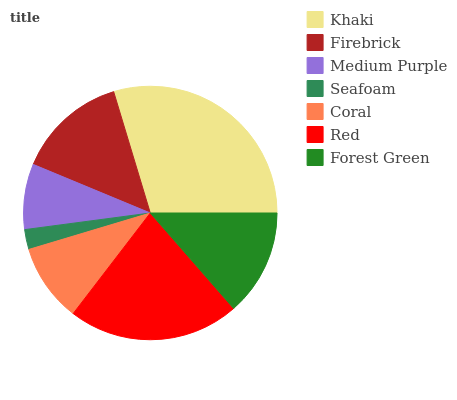Is Seafoam the minimum?
Answer yes or no. Yes. Is Khaki the maximum?
Answer yes or no. Yes. Is Firebrick the minimum?
Answer yes or no. No. Is Firebrick the maximum?
Answer yes or no. No. Is Khaki greater than Firebrick?
Answer yes or no. Yes. Is Firebrick less than Khaki?
Answer yes or no. Yes. Is Firebrick greater than Khaki?
Answer yes or no. No. Is Khaki less than Firebrick?
Answer yes or no. No. Is Forest Green the high median?
Answer yes or no. Yes. Is Forest Green the low median?
Answer yes or no. Yes. Is Firebrick the high median?
Answer yes or no. No. Is Medium Purple the low median?
Answer yes or no. No. 